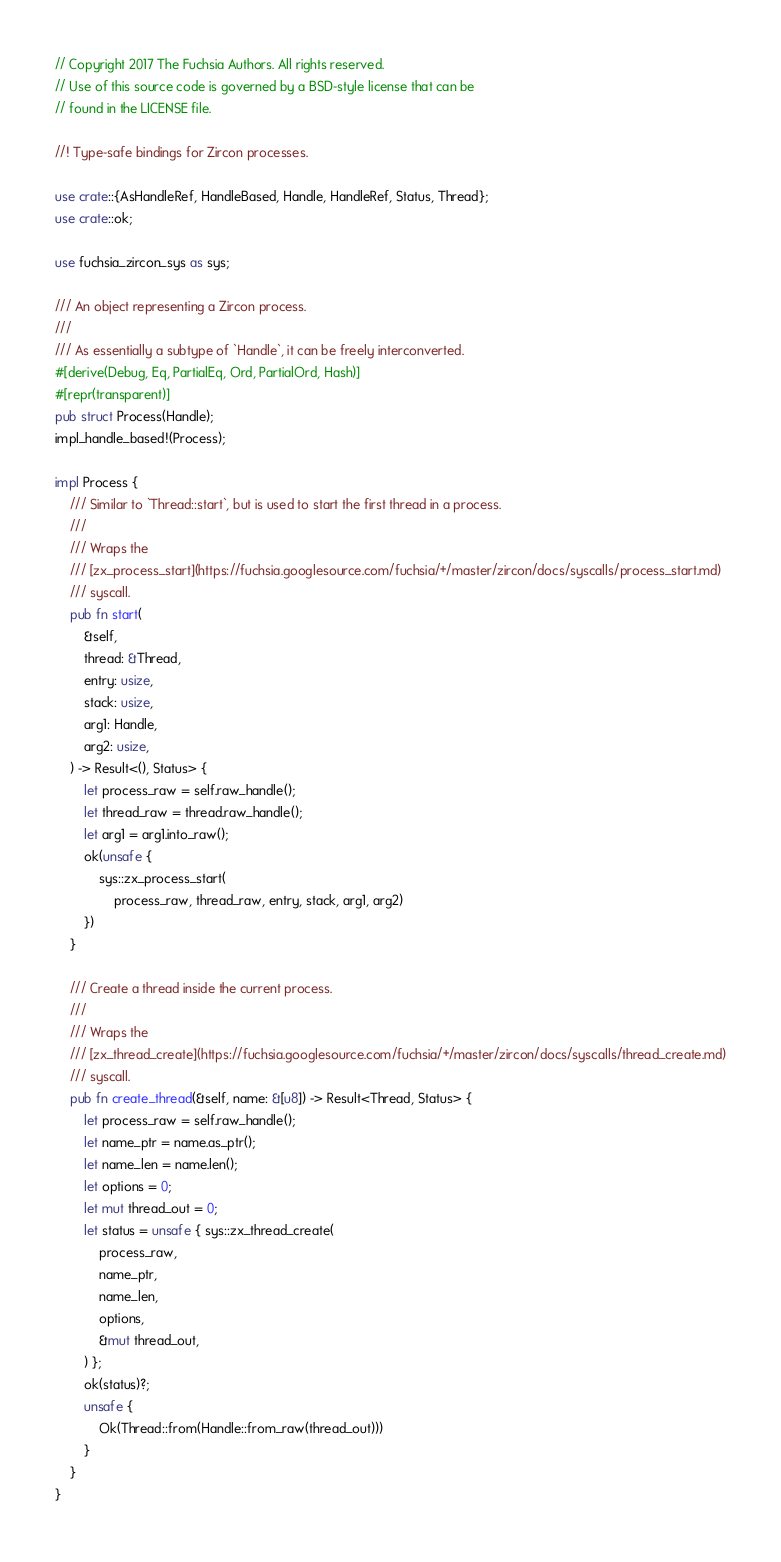Convert code to text. <code><loc_0><loc_0><loc_500><loc_500><_Rust_>// Copyright 2017 The Fuchsia Authors. All rights reserved.
// Use of this source code is governed by a BSD-style license that can be
// found in the LICENSE file.

//! Type-safe bindings for Zircon processes.

use crate::{AsHandleRef, HandleBased, Handle, HandleRef, Status, Thread};
use crate::ok;

use fuchsia_zircon_sys as sys;

/// An object representing a Zircon process.
///
/// As essentially a subtype of `Handle`, it can be freely interconverted.
#[derive(Debug, Eq, PartialEq, Ord, PartialOrd, Hash)]
#[repr(transparent)]
pub struct Process(Handle);
impl_handle_based!(Process);

impl Process {
    /// Similar to `Thread::start`, but is used to start the first thread in a process.
    ///
    /// Wraps the
    /// [zx_process_start](https://fuchsia.googlesource.com/fuchsia/+/master/zircon/docs/syscalls/process_start.md)
    /// syscall.
    pub fn start(
        &self,
        thread: &Thread,
        entry: usize,
        stack: usize,
        arg1: Handle,
        arg2: usize,
    ) -> Result<(), Status> {
        let process_raw = self.raw_handle();
        let thread_raw = thread.raw_handle();
        let arg1 = arg1.into_raw();
        ok(unsafe {
            sys::zx_process_start(
                process_raw, thread_raw, entry, stack, arg1, arg2)
        })
    }

    /// Create a thread inside the current process.
    ///
    /// Wraps the
    /// [zx_thread_create](https://fuchsia.googlesource.com/fuchsia/+/master/zircon/docs/syscalls/thread_create.md)
    /// syscall.
    pub fn create_thread(&self, name: &[u8]) -> Result<Thread, Status> {
        let process_raw = self.raw_handle();
        let name_ptr = name.as_ptr();
        let name_len = name.len();
        let options = 0;
        let mut thread_out = 0;
        let status = unsafe { sys::zx_thread_create(
            process_raw,
            name_ptr,
            name_len,
            options,
            &mut thread_out,
        ) };
        ok(status)?;
        unsafe {
            Ok(Thread::from(Handle::from_raw(thread_out)))
        }
    }
}
</code> 